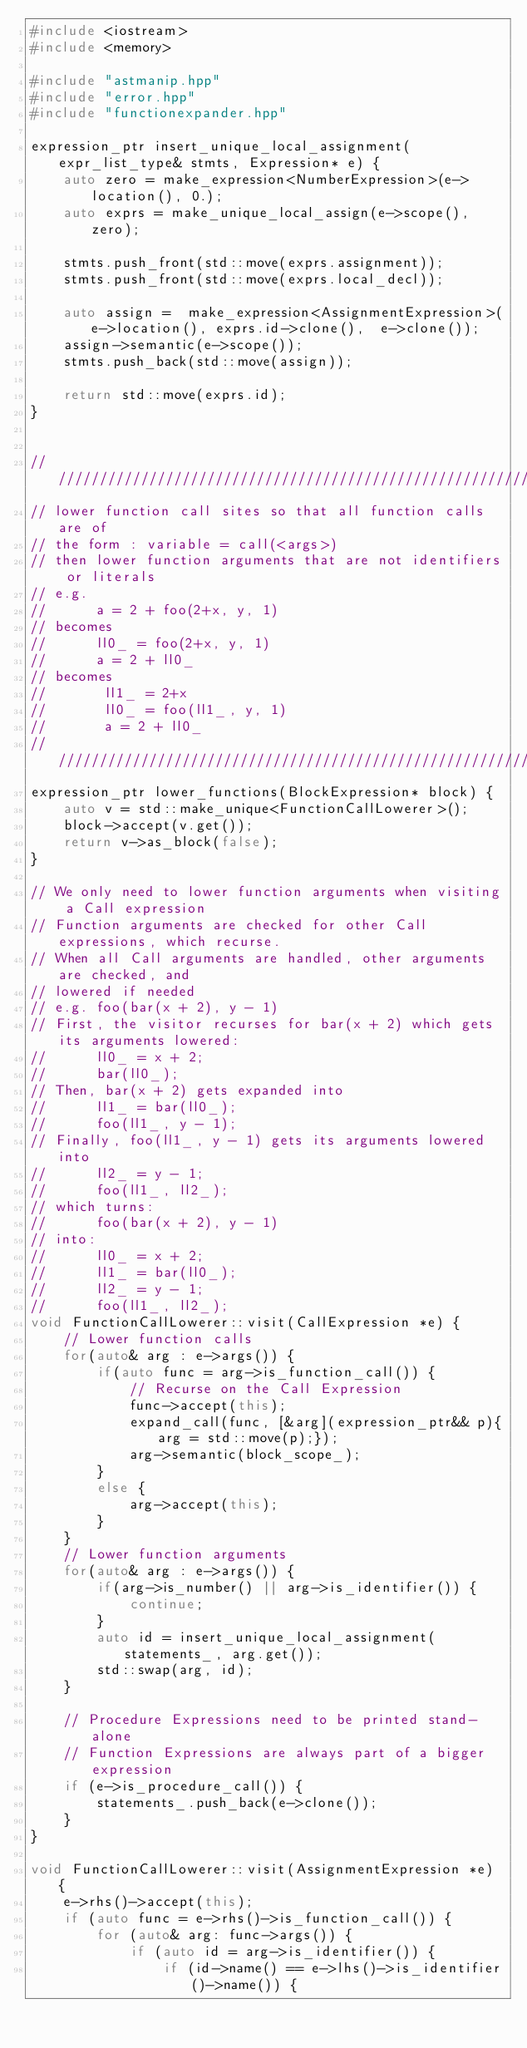<code> <loc_0><loc_0><loc_500><loc_500><_C++_>#include <iostream>
#include <memory>

#include "astmanip.hpp"
#include "error.hpp"
#include "functionexpander.hpp"

expression_ptr insert_unique_local_assignment(expr_list_type& stmts, Expression* e) {
    auto zero = make_expression<NumberExpression>(e->location(), 0.);
    auto exprs = make_unique_local_assign(e->scope(), zero);

    stmts.push_front(std::move(exprs.assignment));
    stmts.push_front(std::move(exprs.local_decl));

    auto assign =  make_expression<AssignmentExpression>(e->location(), exprs.id->clone(),  e->clone());
    assign->semantic(e->scope());
    stmts.push_back(std::move(assign));

    return std::move(exprs.id);
}


/////////////////////////////////////////////////////////////////////
// lower function call sites so that all function calls are of
// the form : variable = call(<args>)
// then lower function arguments that are not identifiers or literals
// e.g.
//      a = 2 + foo(2+x, y, 1)
// becomes
//      ll0_ = foo(2+x, y, 1)
//      a = 2 + ll0_
// becomes
//       ll1_ = 2+x
//       ll0_ = foo(ll1_, y, 1)
//       a = 2 + ll0_
/////////////////////////////////////////////////////////////////////
expression_ptr lower_functions(BlockExpression* block) {
    auto v = std::make_unique<FunctionCallLowerer>();
    block->accept(v.get());
    return v->as_block(false);
}

// We only need to lower function arguments when visiting a Call expression
// Function arguments are checked for other Call expressions, which recurse.
// When all Call arguments are handled, other arguments are checked, and
// lowered if needed
// e.g. foo(bar(x + 2), y - 1)
// First, the visitor recurses for bar(x + 2) which gets its arguments lowered:
//      ll0_ = x + 2;
//      bar(ll0_);
// Then, bar(x + 2) gets expanded into
//      ll1_ = bar(ll0_);
//      foo(ll1_, y - 1);
// Finally, foo(ll1_, y - 1) gets its arguments lowered into
//      ll2_ = y - 1;
//      foo(ll1_, ll2_);
// which turns:
//      foo(bar(x + 2), y - 1)
// into:
//      ll0_ = x + 2;
//      ll1_ = bar(ll0_);
//      ll2_ = y - 1;
//      foo(ll1_, ll2_);
void FunctionCallLowerer::visit(CallExpression *e) {
    // Lower function calls
    for(auto& arg : e->args()) {
        if(auto func = arg->is_function_call()) {
            // Recurse on the Call Expression
            func->accept(this);
            expand_call(func, [&arg](expression_ptr&& p){arg = std::move(p);});
            arg->semantic(block_scope_);
        }
        else {
            arg->accept(this);
        }
    }
    // Lower function arguments
    for(auto& arg : e->args()) {
        if(arg->is_number() || arg->is_identifier()) {
            continue;
        }
        auto id = insert_unique_local_assignment(statements_, arg.get());
        std::swap(arg, id);
    }

    // Procedure Expressions need to be printed stand-alone
    // Function Expressions are always part of a bigger expression
    if (e->is_procedure_call()) {
        statements_.push_back(e->clone());
    }
}

void FunctionCallLowerer::visit(AssignmentExpression *e) {
    e->rhs()->accept(this);
    if (auto func = e->rhs()->is_function_call()) {
        for (auto& arg: func->args()) {
            if (auto id = arg->is_identifier()) {
                if (id->name() == e->lhs()->is_identifier()->name()) {</code> 